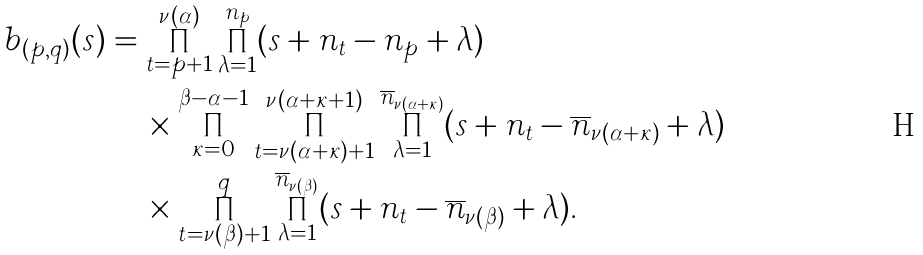<formula> <loc_0><loc_0><loc_500><loc_500>b _ { ( p , q ) } ( s ) & = \prod _ { t = p + 1 } ^ { \nu ( \alpha ) } \prod _ { \lambda = 1 } ^ { n _ { p } } ( s + n _ { t } - n _ { p } + \lambda ) \\ & \quad \, \times \prod _ { \kappa = 0 } ^ { \beta - \alpha - 1 } \prod _ { t = \nu ( \alpha + \kappa ) + 1 } ^ { \nu ( \alpha + \kappa + 1 ) } \prod _ { \lambda = 1 } ^ { \overline { n } _ { \nu ( \alpha + \kappa ) } } ( s + n _ { t } - \overline { n } _ { \nu ( \alpha + \kappa ) } + \lambda ) \\ & \quad \, \times \prod _ { t = \nu ( \beta ) + 1 } ^ { q } \prod _ { \lambda = 1 } ^ { \overline { n } _ { \nu ( \beta ) } } ( s + n _ { t } - \overline { n } _ { \nu ( \beta ) } + \lambda ) .</formula> 